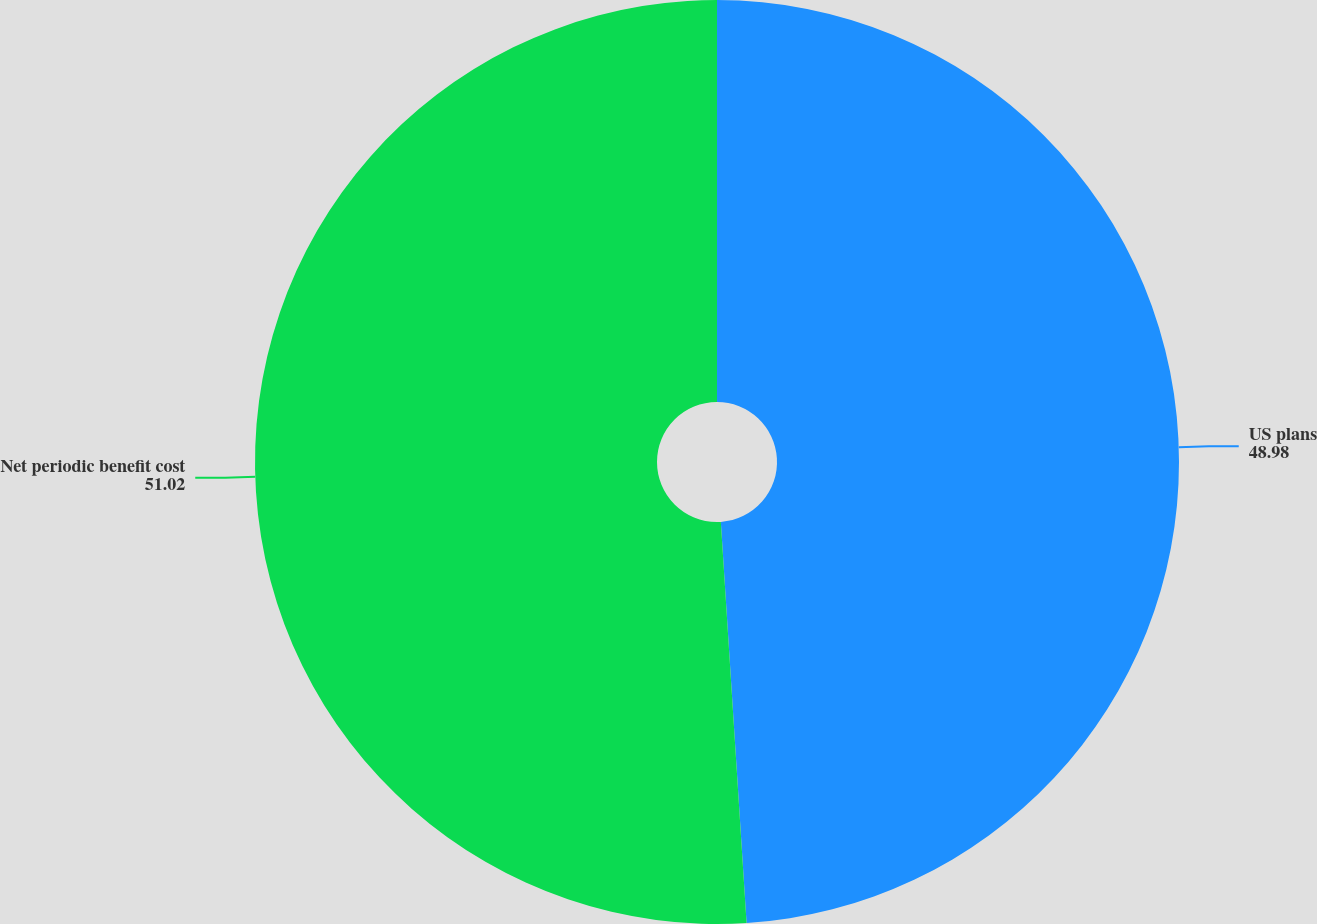<chart> <loc_0><loc_0><loc_500><loc_500><pie_chart><fcel>US plans<fcel>Net periodic benefit cost<nl><fcel>48.98%<fcel>51.02%<nl></chart> 